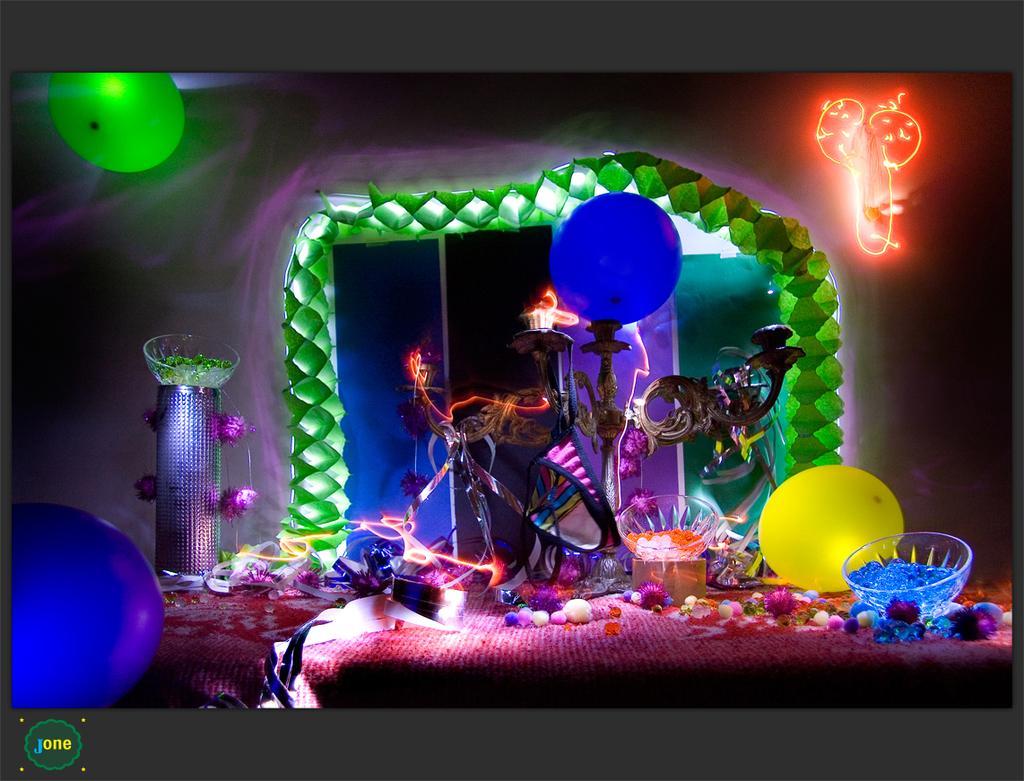How would you summarize this image in a sentence or two? In this image we can see a few balloons, bowls, a bowl on a stand, a box and few objects looks like a decorative items. 